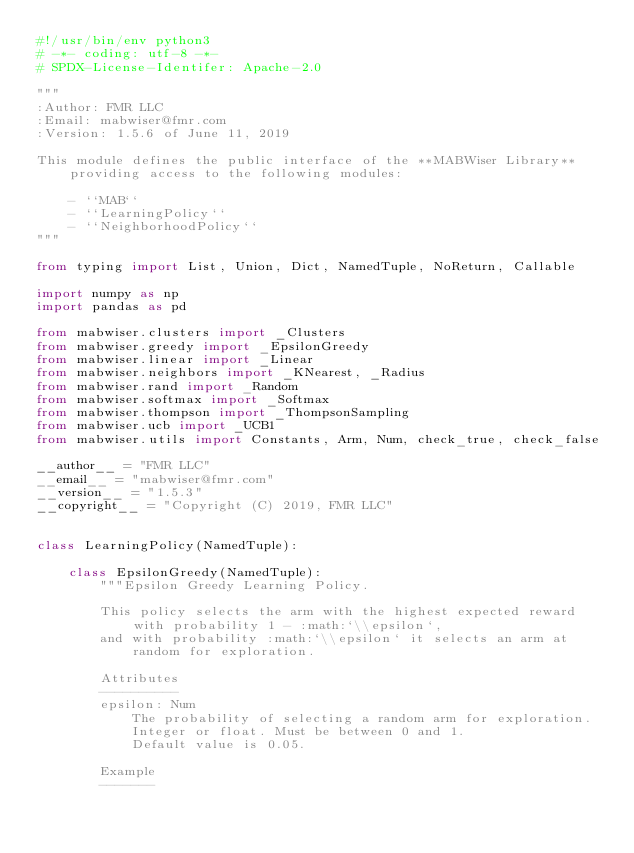<code> <loc_0><loc_0><loc_500><loc_500><_Python_>#!/usr/bin/env python3
# -*- coding: utf-8 -*-
# SPDX-License-Identifer: Apache-2.0

"""
:Author: FMR LLC
:Email: mabwiser@fmr.com
:Version: 1.5.6 of June 11, 2019

This module defines the public interface of the **MABWiser Library** providing access to the following modules:

    - ``MAB``
    - ``LearningPolicy``
    - ``NeighborhoodPolicy``
"""

from typing import List, Union, Dict, NamedTuple, NoReturn, Callable

import numpy as np
import pandas as pd

from mabwiser.clusters import _Clusters
from mabwiser.greedy import _EpsilonGreedy
from mabwiser.linear import _Linear
from mabwiser.neighbors import _KNearest, _Radius
from mabwiser.rand import _Random
from mabwiser.softmax import _Softmax
from mabwiser.thompson import _ThompsonSampling
from mabwiser.ucb import _UCB1
from mabwiser.utils import Constants, Arm, Num, check_true, check_false

__author__ = "FMR LLC"
__email__ = "mabwiser@fmr.com"
__version__ = "1.5.3"
__copyright__ = "Copyright (C) 2019, FMR LLC"


class LearningPolicy(NamedTuple):

    class EpsilonGreedy(NamedTuple):
        """Epsilon Greedy Learning Policy.

        This policy selects the arm with the highest expected reward with probability 1 - :math:`\\epsilon`,
        and with probability :math:`\\epsilon` it selects an arm at random for exploration.

        Attributes
        ----------
        epsilon: Num
            The probability of selecting a random arm for exploration.
            Integer or float. Must be between 0 and 1.
            Default value is 0.05.
        
        Example
        -------</code> 